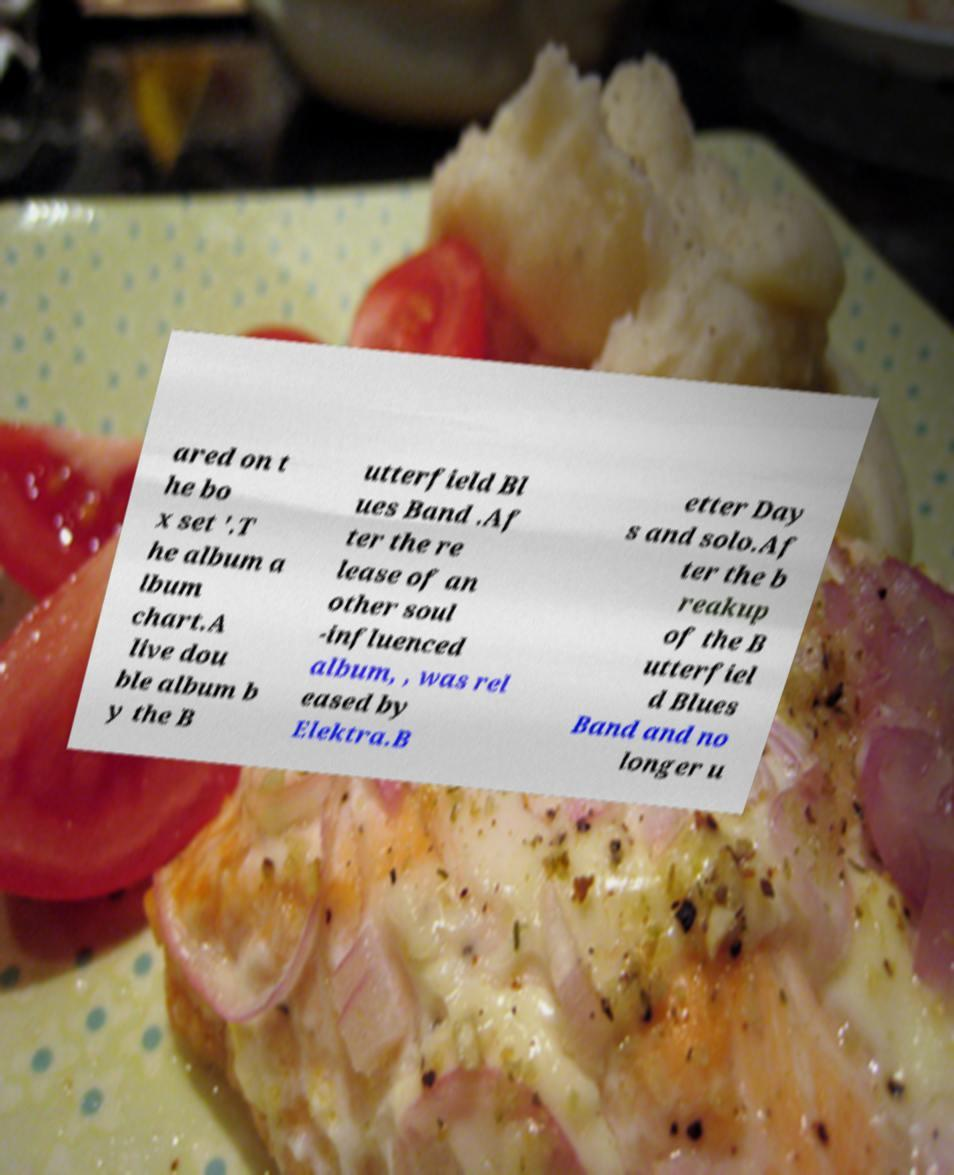For documentation purposes, I need the text within this image transcribed. Could you provide that? ared on t he bo x set '.T he album a lbum chart.A live dou ble album b y the B utterfield Bl ues Band .Af ter the re lease of an other soul -influenced album, , was rel eased by Elektra.B etter Day s and solo.Af ter the b reakup of the B utterfiel d Blues Band and no longer u 